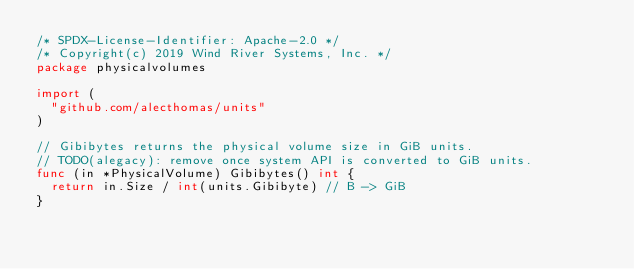Convert code to text. <code><loc_0><loc_0><loc_500><loc_500><_Go_>/* SPDX-License-Identifier: Apache-2.0 */
/* Copyright(c) 2019 Wind River Systems, Inc. */
package physicalvolumes

import (
	"github.com/alecthomas/units"
)

// Gibibytes returns the physical volume size in GiB units.
// TODO(alegacy): remove once system API is converted to GiB units.
func (in *PhysicalVolume) Gibibytes() int {
	return in.Size / int(units.Gibibyte) // B -> GiB
}
</code> 